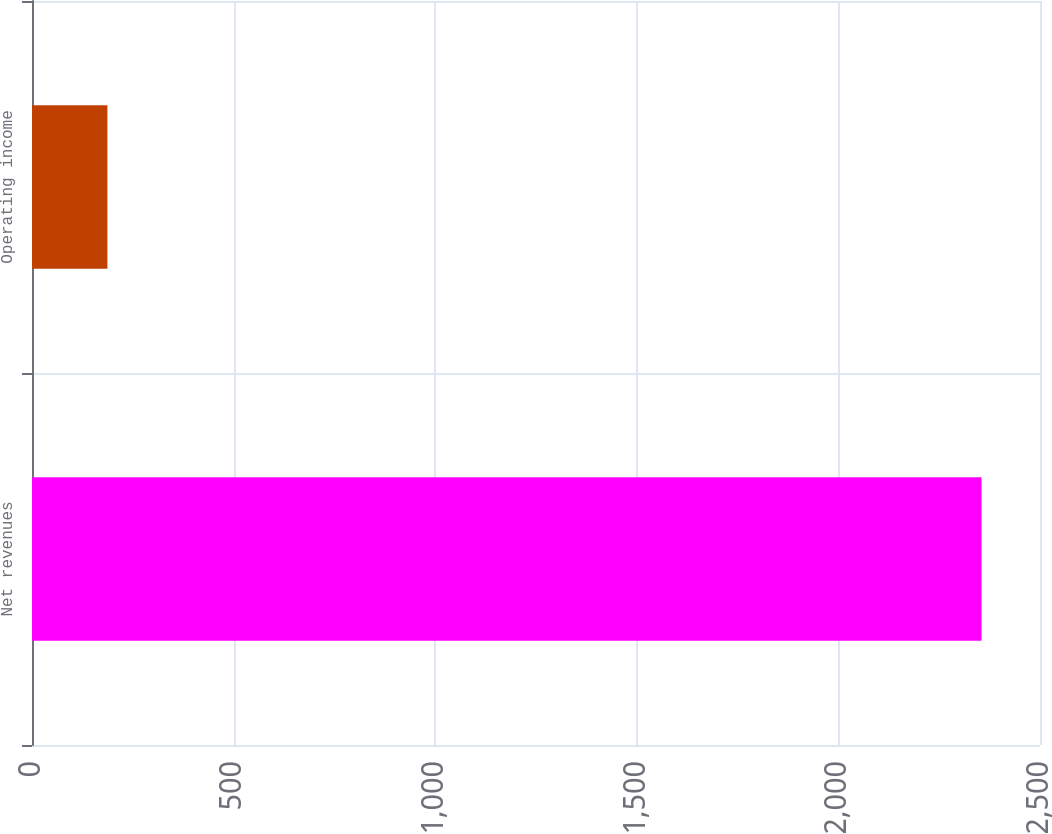Convert chart. <chart><loc_0><loc_0><loc_500><loc_500><bar_chart><fcel>Net revenues<fcel>Operating income<nl><fcel>2355<fcel>187<nl></chart> 